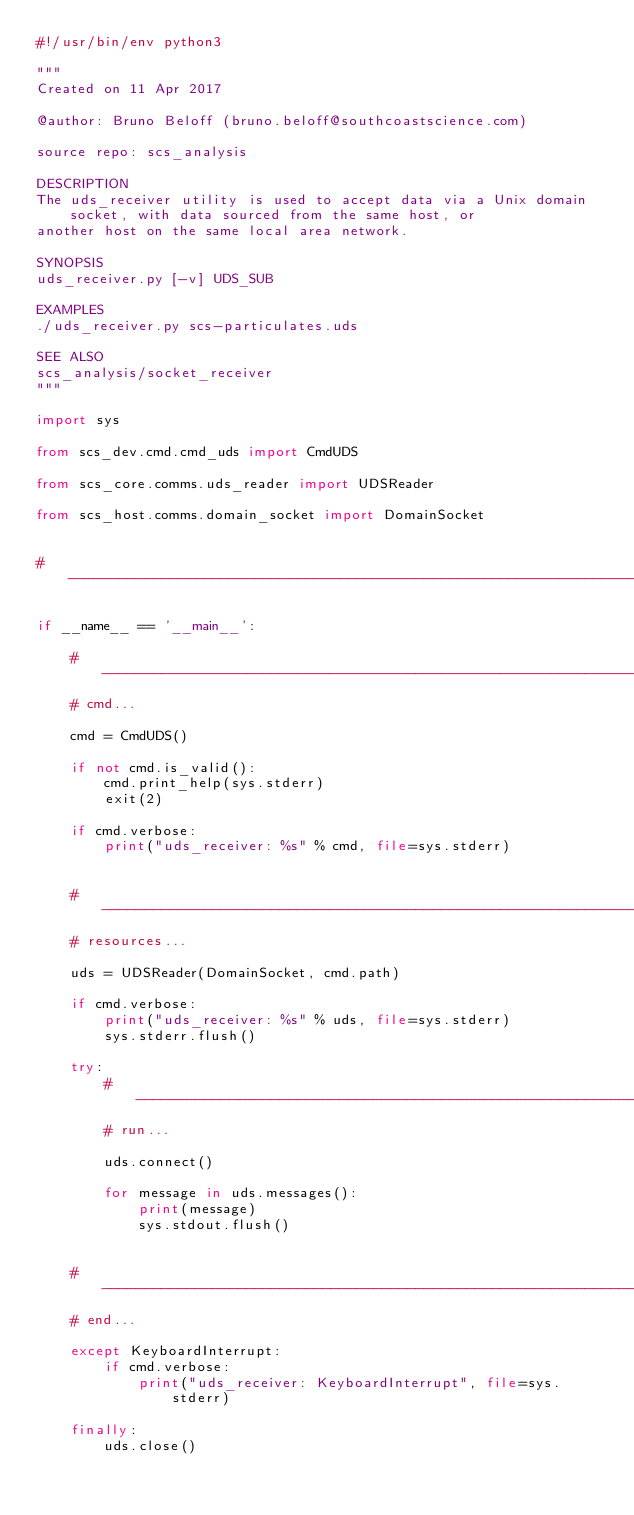Convert code to text. <code><loc_0><loc_0><loc_500><loc_500><_Python_>#!/usr/bin/env python3

"""
Created on 11 Apr 2017

@author: Bruno Beloff (bruno.beloff@southcoastscience.com)

source repo: scs_analysis

DESCRIPTION
The uds_receiver utility is used to accept data via a Unix domain socket, with data sourced from the same host, or
another host on the same local area network.

SYNOPSIS
uds_receiver.py [-v] UDS_SUB

EXAMPLES
./uds_receiver.py scs-particulates.uds

SEE ALSO
scs_analysis/socket_receiver
"""

import sys

from scs_dev.cmd.cmd_uds import CmdUDS

from scs_core.comms.uds_reader import UDSReader

from scs_host.comms.domain_socket import DomainSocket


# --------------------------------------------------------------------------------------------------------------------

if __name__ == '__main__':

    # ----------------------------------------------------------------------------------------------------------------
    # cmd...

    cmd = CmdUDS()

    if not cmd.is_valid():
        cmd.print_help(sys.stderr)
        exit(2)

    if cmd.verbose:
        print("uds_receiver: %s" % cmd, file=sys.stderr)


    # ----------------------------------------------------------------------------------------------------------------
    # resources...

    uds = UDSReader(DomainSocket, cmd.path)

    if cmd.verbose:
        print("uds_receiver: %s" % uds, file=sys.stderr)
        sys.stderr.flush()

    try:
        # ------------------------------------------------------------------------------------------------------------
        # run...

        uds.connect()

        for message in uds.messages():
            print(message)
            sys.stdout.flush()


    # ----------------------------------------------------------------------------------------------------------------
    # end...

    except KeyboardInterrupt:
        if cmd.verbose:
            print("uds_receiver: KeyboardInterrupt", file=sys.stderr)

    finally:
        uds.close()
</code> 